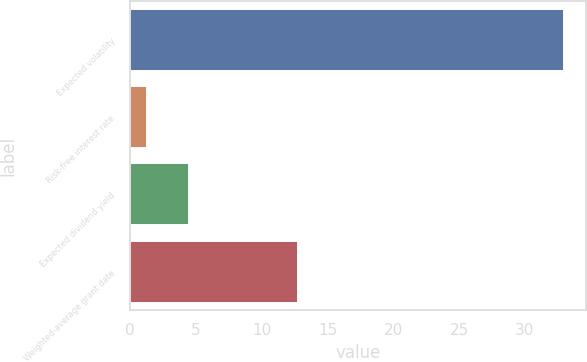Convert chart to OTSL. <chart><loc_0><loc_0><loc_500><loc_500><bar_chart><fcel>Expected volatility<fcel>Risk-free interest rate<fcel>Expected dividend yield<fcel>Weighted-average grant date<nl><fcel>33<fcel>1.3<fcel>4.47<fcel>12.77<nl></chart> 